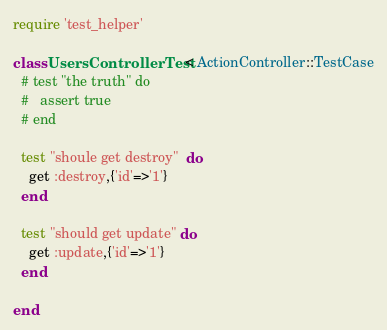<code> <loc_0><loc_0><loc_500><loc_500><_Ruby_>require 'test_helper'

class UsersControllerTest < ActionController::TestCase
  # test "the truth" do
  #   assert true
  # end

  test "shoule get destroy"  do
    get :destroy,{'id'=>'1'}
  end

  test "should get update" do
    get :update,{'id'=>'1'}
  end

end
</code> 